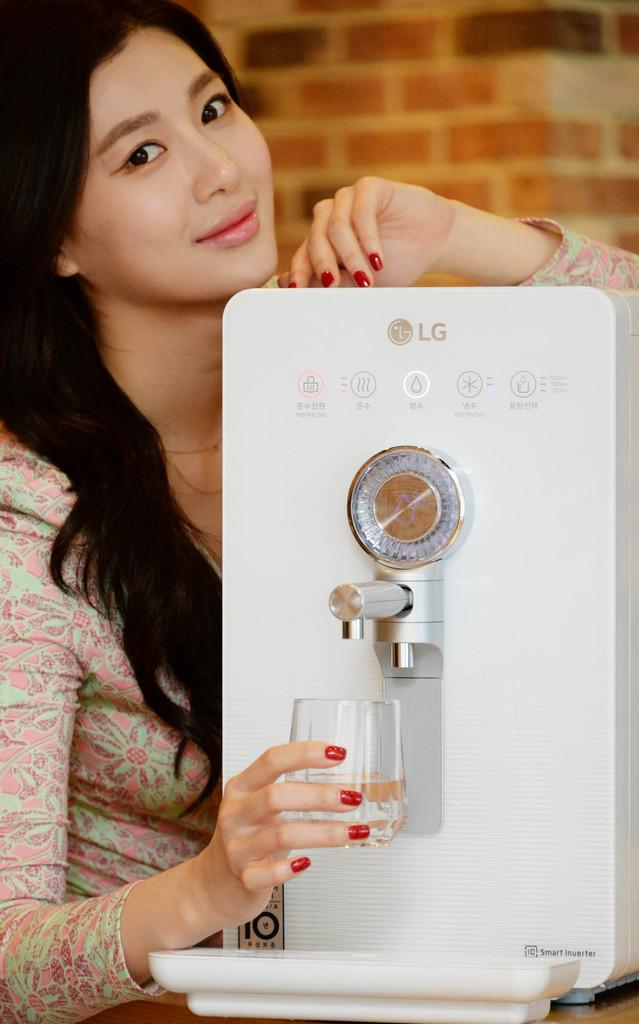<image>
Relay a brief, clear account of the picture shown. A lady pouring some water from the LG machine. 